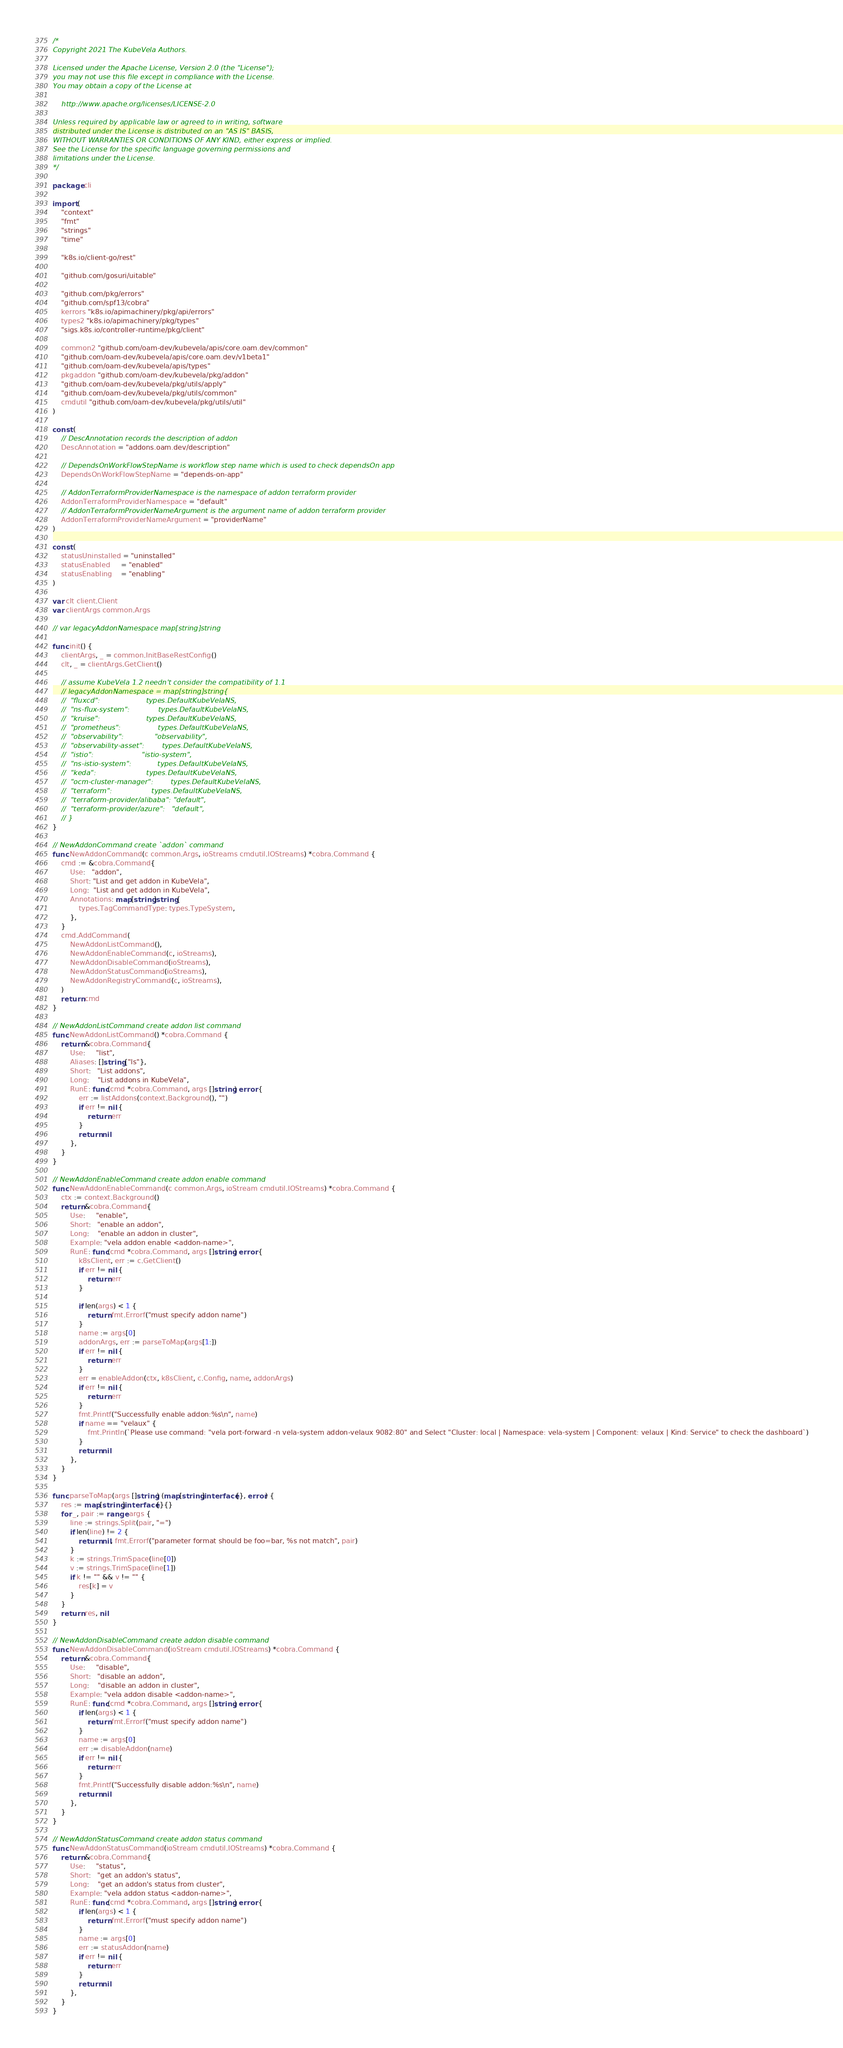Convert code to text. <code><loc_0><loc_0><loc_500><loc_500><_Go_>/*
Copyright 2021 The KubeVela Authors.

Licensed under the Apache License, Version 2.0 (the "License");
you may not use this file except in compliance with the License.
You may obtain a copy of the License at

    http://www.apache.org/licenses/LICENSE-2.0

Unless required by applicable law or agreed to in writing, software
distributed under the License is distributed on an "AS IS" BASIS,
WITHOUT WARRANTIES OR CONDITIONS OF ANY KIND, either express or implied.
See the License for the specific language governing permissions and
limitations under the License.
*/

package cli

import (
	"context"
	"fmt"
	"strings"
	"time"

	"k8s.io/client-go/rest"

	"github.com/gosuri/uitable"

	"github.com/pkg/errors"
	"github.com/spf13/cobra"
	kerrors "k8s.io/apimachinery/pkg/api/errors"
	types2 "k8s.io/apimachinery/pkg/types"
	"sigs.k8s.io/controller-runtime/pkg/client"

	common2 "github.com/oam-dev/kubevela/apis/core.oam.dev/common"
	"github.com/oam-dev/kubevela/apis/core.oam.dev/v1beta1"
	"github.com/oam-dev/kubevela/apis/types"
	pkgaddon "github.com/oam-dev/kubevela/pkg/addon"
	"github.com/oam-dev/kubevela/pkg/utils/apply"
	"github.com/oam-dev/kubevela/pkg/utils/common"
	cmdutil "github.com/oam-dev/kubevela/pkg/utils/util"
)

const (
	// DescAnnotation records the description of addon
	DescAnnotation = "addons.oam.dev/description"

	// DependsOnWorkFlowStepName is workflow step name which is used to check dependsOn app
	DependsOnWorkFlowStepName = "depends-on-app"

	// AddonTerraformProviderNamespace is the namespace of addon terraform provider
	AddonTerraformProviderNamespace = "default"
	// AddonTerraformProviderNameArgument is the argument name of addon terraform provider
	AddonTerraformProviderNameArgument = "providerName"
)

const (
	statusUninstalled = "uninstalled"
	statusEnabled     = "enabled"
	statusEnabling    = "enabling"
)

var clt client.Client
var clientArgs common.Args

// var legacyAddonNamespace map[string]string

func init() {
	clientArgs, _ = common.InitBaseRestConfig()
	clt, _ = clientArgs.GetClient()

	// assume KubeVela 1.2 needn't consider the compatibility of 1.1
	// legacyAddonNamespace = map[string]string{
	//	"fluxcd":                     types.DefaultKubeVelaNS,
	//	"ns-flux-system":             types.DefaultKubeVelaNS,
	//	"kruise":                     types.DefaultKubeVelaNS,
	//	"prometheus":                 types.DefaultKubeVelaNS,
	//	"observability":              "observability",
	//	"observability-asset":        types.DefaultKubeVelaNS,
	//	"istio":                      "istio-system",
	//	"ns-istio-system":            types.DefaultKubeVelaNS,
	//	"keda":                       types.DefaultKubeVelaNS,
	//	"ocm-cluster-manager":        types.DefaultKubeVelaNS,
	//	"terraform":                  types.DefaultKubeVelaNS,
	//	"terraform-provider/alibaba": "default",
	//	"terraform-provider/azure":   "default",
	// }
}

// NewAddonCommand create `addon` command
func NewAddonCommand(c common.Args, ioStreams cmdutil.IOStreams) *cobra.Command {
	cmd := &cobra.Command{
		Use:   "addon",
		Short: "List and get addon in KubeVela",
		Long:  "List and get addon in KubeVela",
		Annotations: map[string]string{
			types.TagCommandType: types.TypeSystem,
		},
	}
	cmd.AddCommand(
		NewAddonListCommand(),
		NewAddonEnableCommand(c, ioStreams),
		NewAddonDisableCommand(ioStreams),
		NewAddonStatusCommand(ioStreams),
		NewAddonRegistryCommand(c, ioStreams),
	)
	return cmd
}

// NewAddonListCommand create addon list command
func NewAddonListCommand() *cobra.Command {
	return &cobra.Command{
		Use:     "list",
		Aliases: []string{"ls"},
		Short:   "List addons",
		Long:    "List addons in KubeVela",
		RunE: func(cmd *cobra.Command, args []string) error {
			err := listAddons(context.Background(), "")
			if err != nil {
				return err
			}
			return nil
		},
	}
}

// NewAddonEnableCommand create addon enable command
func NewAddonEnableCommand(c common.Args, ioStream cmdutil.IOStreams) *cobra.Command {
	ctx := context.Background()
	return &cobra.Command{
		Use:     "enable",
		Short:   "enable an addon",
		Long:    "enable an addon in cluster",
		Example: "vela addon enable <addon-name>",
		RunE: func(cmd *cobra.Command, args []string) error {
			k8sClient, err := c.GetClient()
			if err != nil {
				return err
			}

			if len(args) < 1 {
				return fmt.Errorf("must specify addon name")
			}
			name := args[0]
			addonArgs, err := parseToMap(args[1:])
			if err != nil {
				return err
			}
			err = enableAddon(ctx, k8sClient, c.Config, name, addonArgs)
			if err != nil {
				return err
			}
			fmt.Printf("Successfully enable addon:%s\n", name)
			if name == "velaux" {
				fmt.Println(`Please use command: "vela port-forward -n vela-system addon-velaux 9082:80" and Select "Cluster: local | Namespace: vela-system | Component: velaux | Kind: Service" to check the dashboard`)
			}
			return nil
		},
	}
}

func parseToMap(args []string) (map[string]interface{}, error) {
	res := map[string]interface{}{}
	for _, pair := range args {
		line := strings.Split(pair, "=")
		if len(line) != 2 {
			return nil, fmt.Errorf("parameter format should be foo=bar, %s not match", pair)
		}
		k := strings.TrimSpace(line[0])
		v := strings.TrimSpace(line[1])
		if k != "" && v != "" {
			res[k] = v
		}
	}
	return res, nil
}

// NewAddonDisableCommand create addon disable command
func NewAddonDisableCommand(ioStream cmdutil.IOStreams) *cobra.Command {
	return &cobra.Command{
		Use:     "disable",
		Short:   "disable an addon",
		Long:    "disable an addon in cluster",
		Example: "vela addon disable <addon-name>",
		RunE: func(cmd *cobra.Command, args []string) error {
			if len(args) < 1 {
				return fmt.Errorf("must specify addon name")
			}
			name := args[0]
			err := disableAddon(name)
			if err != nil {
				return err
			}
			fmt.Printf("Successfully disable addon:%s\n", name)
			return nil
		},
	}
}

// NewAddonStatusCommand create addon status command
func NewAddonStatusCommand(ioStream cmdutil.IOStreams) *cobra.Command {
	return &cobra.Command{
		Use:     "status",
		Short:   "get an addon's status",
		Long:    "get an addon's status from cluster",
		Example: "vela addon status <addon-name>",
		RunE: func(cmd *cobra.Command, args []string) error {
			if len(args) < 1 {
				return fmt.Errorf("must specify addon name")
			}
			name := args[0]
			err := statusAddon(name)
			if err != nil {
				return err
			}
			return nil
		},
	}
}
</code> 